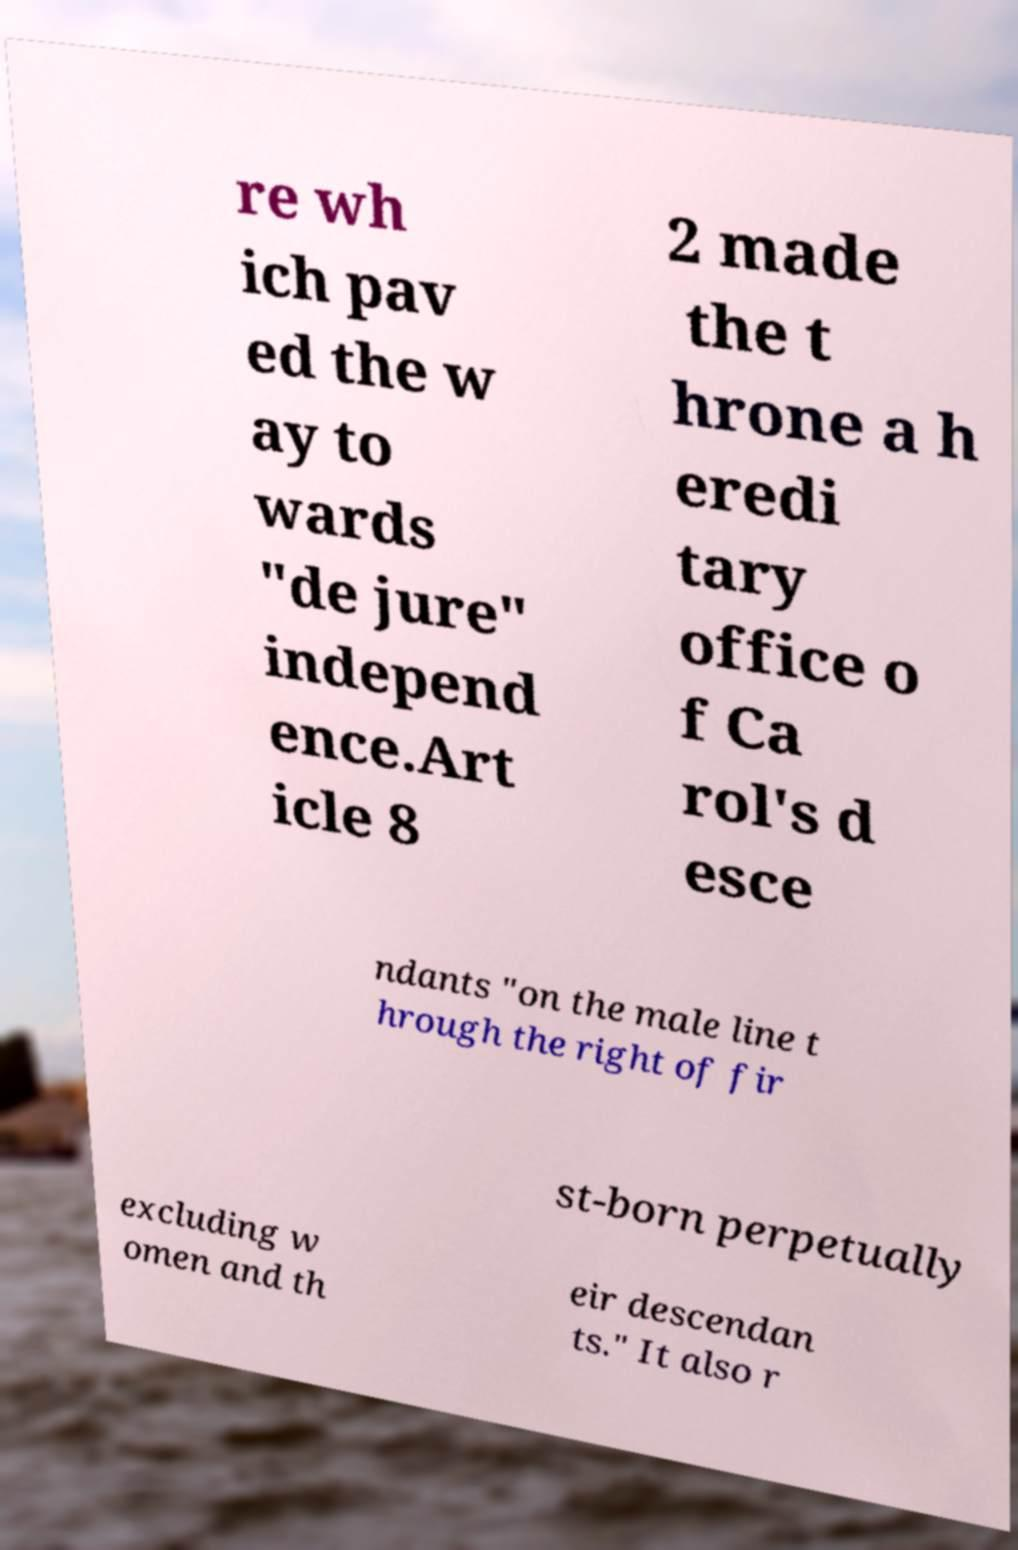I need the written content from this picture converted into text. Can you do that? re wh ich pav ed the w ay to wards "de jure" independ ence.Art icle 8 2 made the t hrone a h eredi tary office o f Ca rol's d esce ndants "on the male line t hrough the right of fir st-born perpetually excluding w omen and th eir descendan ts." It also r 